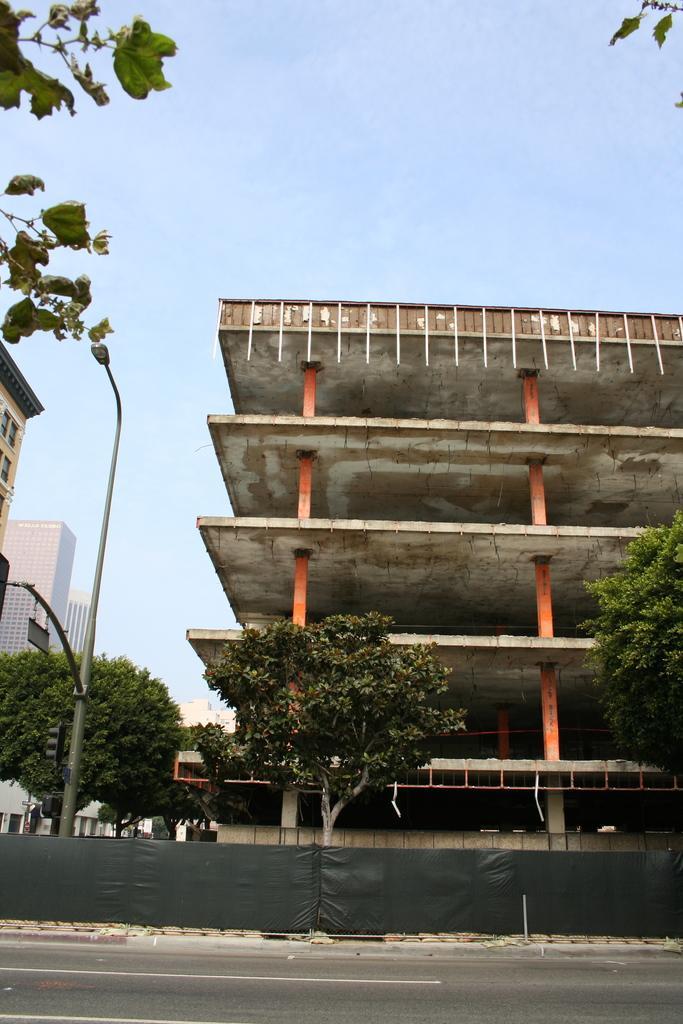Describe this image in one or two sentences. In this image I can see few plants in green color, a light pole, background I can see few buildings in cream, white color and the sky is in blue color. 